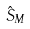<formula> <loc_0><loc_0><loc_500><loc_500>\hat { S } _ { M }</formula> 